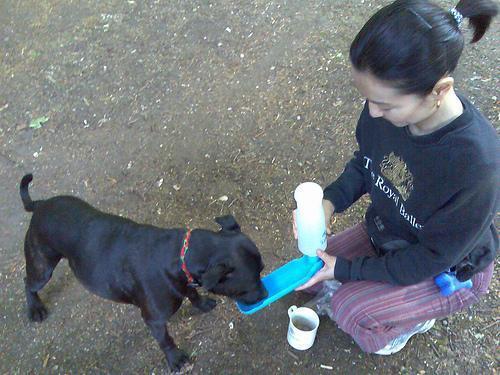How many people are in the picture?
Give a very brief answer. 1. 